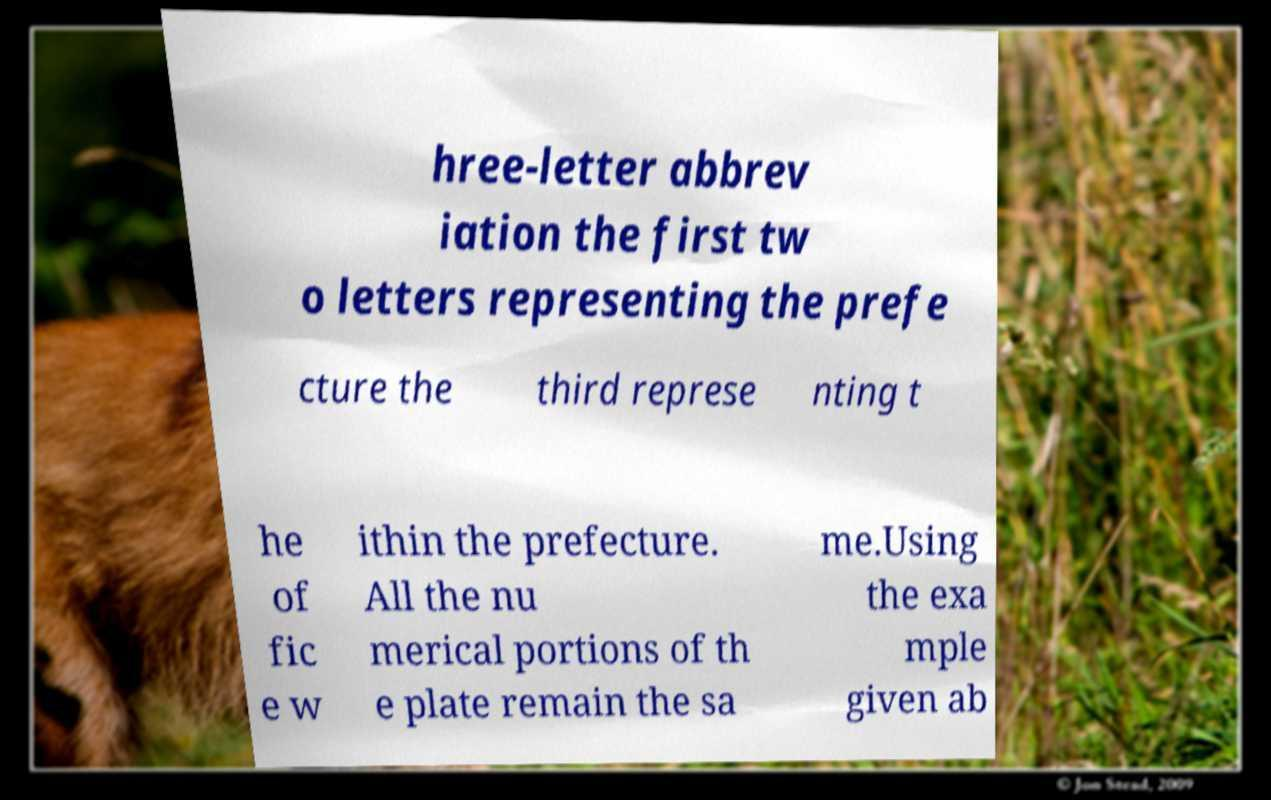Can you accurately transcribe the text from the provided image for me? hree-letter abbrev iation the first tw o letters representing the prefe cture the third represe nting t he of fic e w ithin the prefecture. All the nu merical portions of th e plate remain the sa me.Using the exa mple given ab 